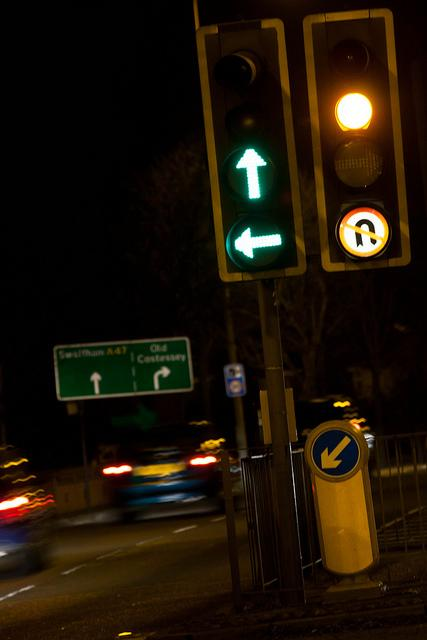What type of signs are these? Please explain your reasoning. traffic signs. The signs direct traffic. 